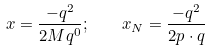<formula> <loc_0><loc_0><loc_500><loc_500>x = \frac { - q ^ { 2 } } { 2 M q ^ { 0 } } ; \quad x _ { N } = \frac { - q ^ { 2 } } { 2 p \cdot q }</formula> 